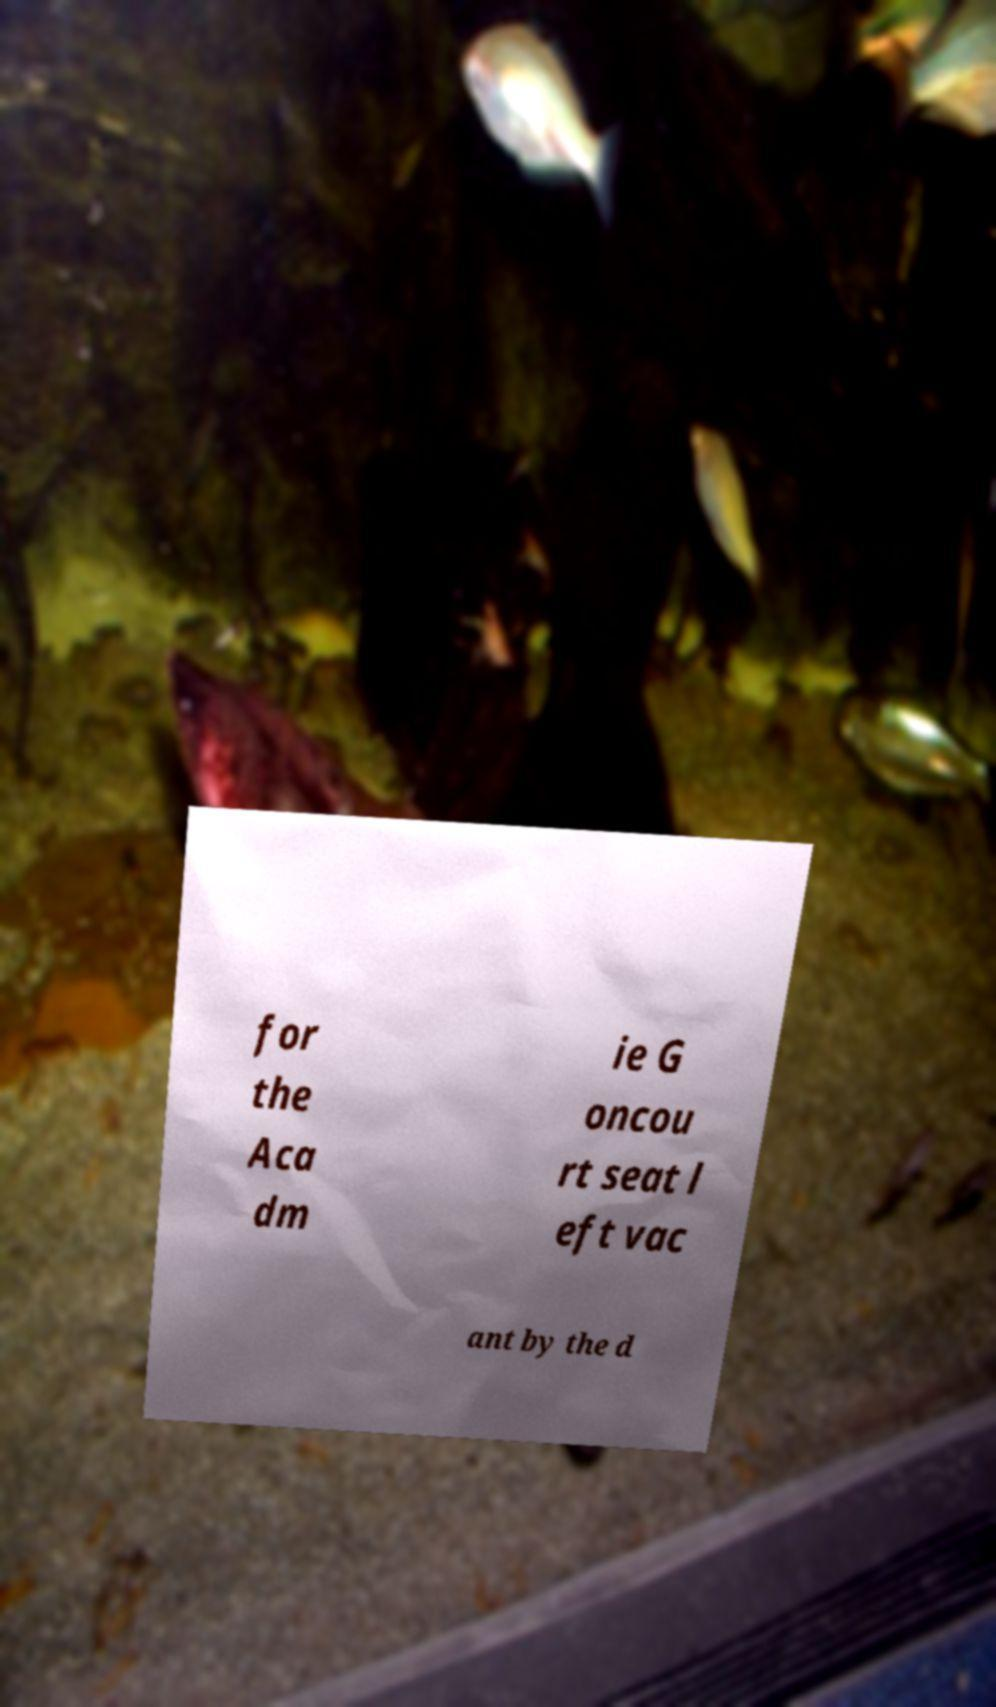Please identify and transcribe the text found in this image. for the Aca dm ie G oncou rt seat l eft vac ant by the d 